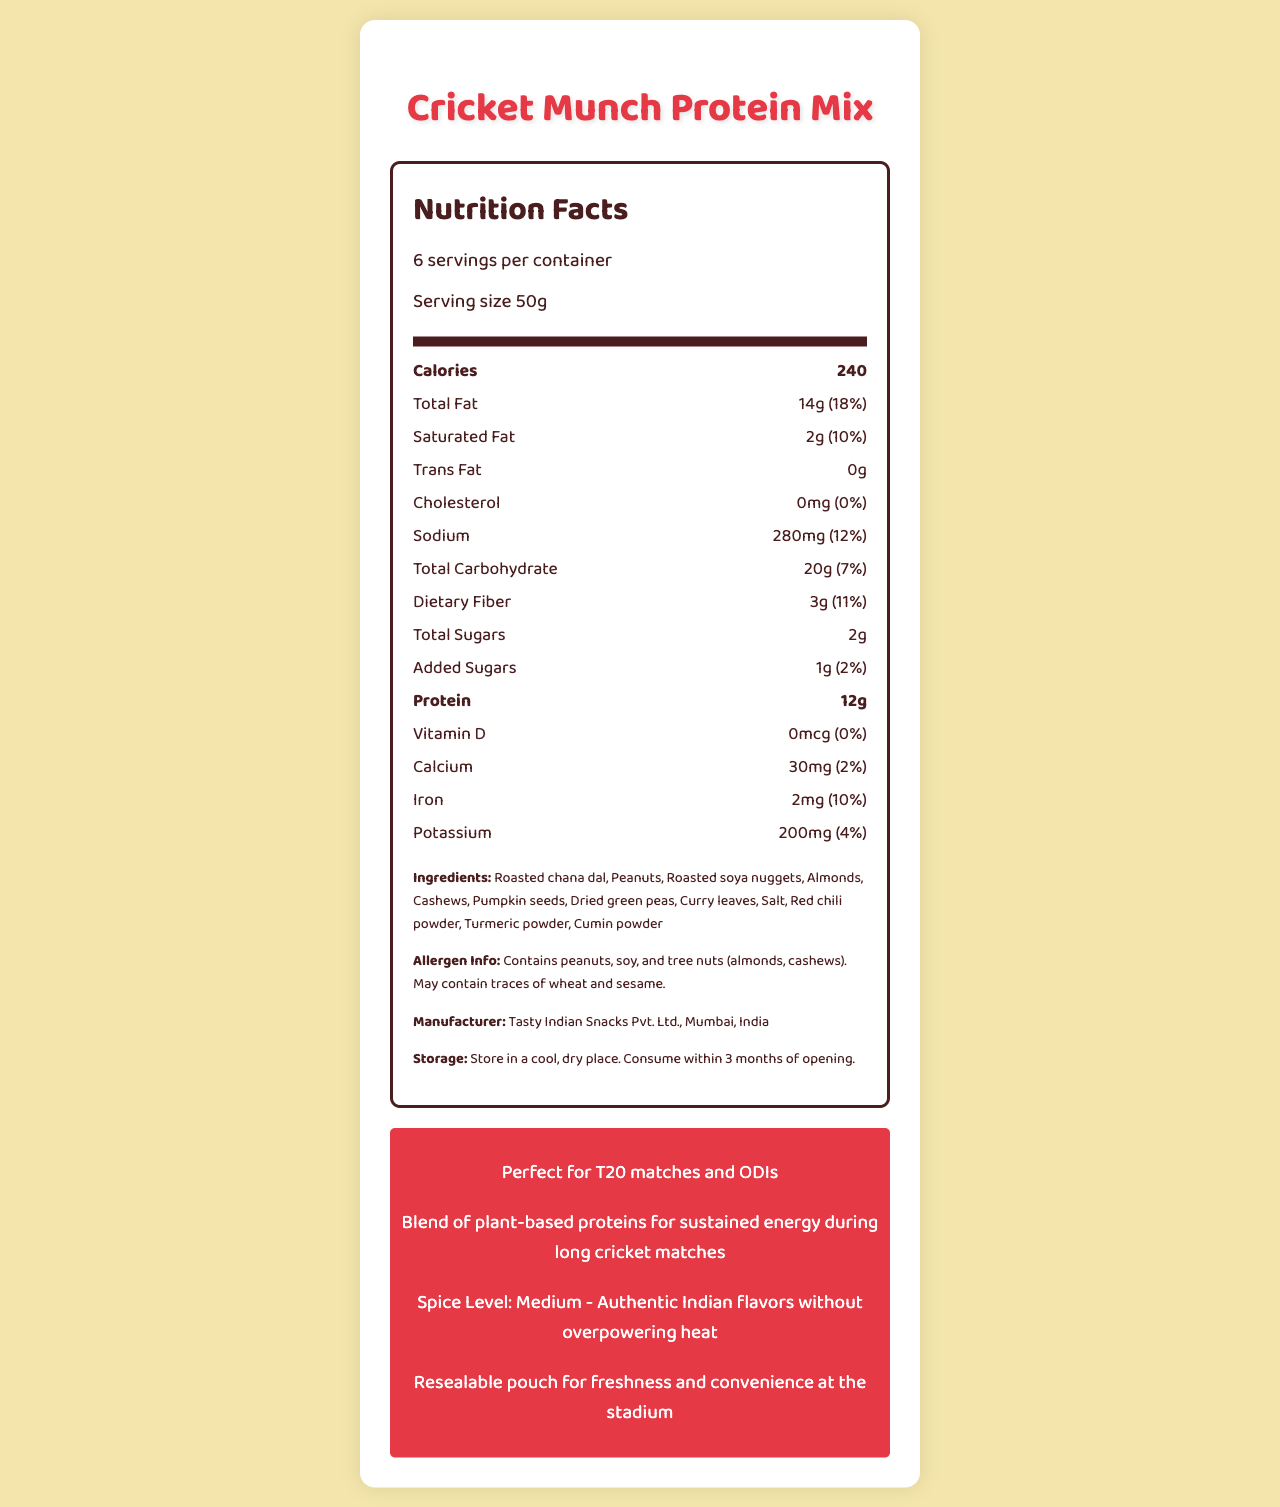what is the serving size of the Cricket Munch Protein Mix? The serving size is specified as "Serving size 50g."
Answer: 50g how many servings are there in a container of Cricket Munch Protein Mix? It is mentioned that there are "6 servings per container."
Answer: 6 servings how many calories are there per serving? The nutrition label lists "Calories 240."
Answer: 240 what is the main source of protein in the Cricket Munch Protein Mix? The document states "Blend of plant-based proteins for sustained energy during long cricket matches."
Answer: Blend of plant-based proteins list any allergens found in the Cricket Munch Protein Mix. The allergen section mentions it "Contains peanuts, soy, and tree nuts (almonds, cashews). May contain traces of wheat and sesame."
Answer: Peanuts, soy, and tree nuts (almonds, cashews) how much daily percentage of total fat does one serving provide? The label states "Total Fat 14g (18%)."
Answer: 18% how much sodium is in one serving, and what is the daily percentage value? The label lists "Sodium 280mg (12%)."
Answer: 280mg, 12% which of the following is not an ingredient in the Cricket Munch Protein Mix? A. Almonds B. Salt C. Sugar The list of ingredients does not include sugar, whereas almonds and salt are listed.
Answer: C. Sugar what percentage of the daily value for iron does one serving of Cricket Munch Protein Mix provide? A. 2%
B. 4%
C. 10% The document lists "Iron 2mg (10%)."
Answer: C. 10% how would you describe the spice level of this snack? The document specifies "Spice level: Medium - Authentic Indian flavors without overpowering heat."
Answer: Medium - Authentic Indian flavors without overpowering heat is vitamin D found in this snack? The label shows "Vitamin D 0mcg (0%)."
Answer: No summarize the main idea of the Cricket Munch Protein Mix document. The document describes the nutritional content and other relevant information of the Cricket Munch Protein Mix, such as serving size, calories, fat and protein content, ingredients, allergens, and storage. It highlights its suitability for cricket match consumption.
Answer: The document provides nutrition facts and other details for Cricket Munch Protein Mix, a protein-rich Indian snack suitable for cricket matches. It includes information on serving size, calories, fat content, and ingredients, as well as allergen information and storage instructions. The snack is intended to provide sustained energy with medium spice levels. what is the name of the manufacturer? The manufacturer information is listed as "Tasty Indian Snacks Pvt. Ltd., Mumbai, India."
Answer: Tasty Indian Snacks Pvt. Ltd., Mumbai, India how long after opening should the Cricket Munch Protein Mix be consumed? The storage instructions state "Consume within 3 months of opening."
Answer: 3 months what other product pairs well with the Cricket Munch Protein Mix? The document does not provide information on any other product that pairs well with this snack.
Answer: Cannot be determined 